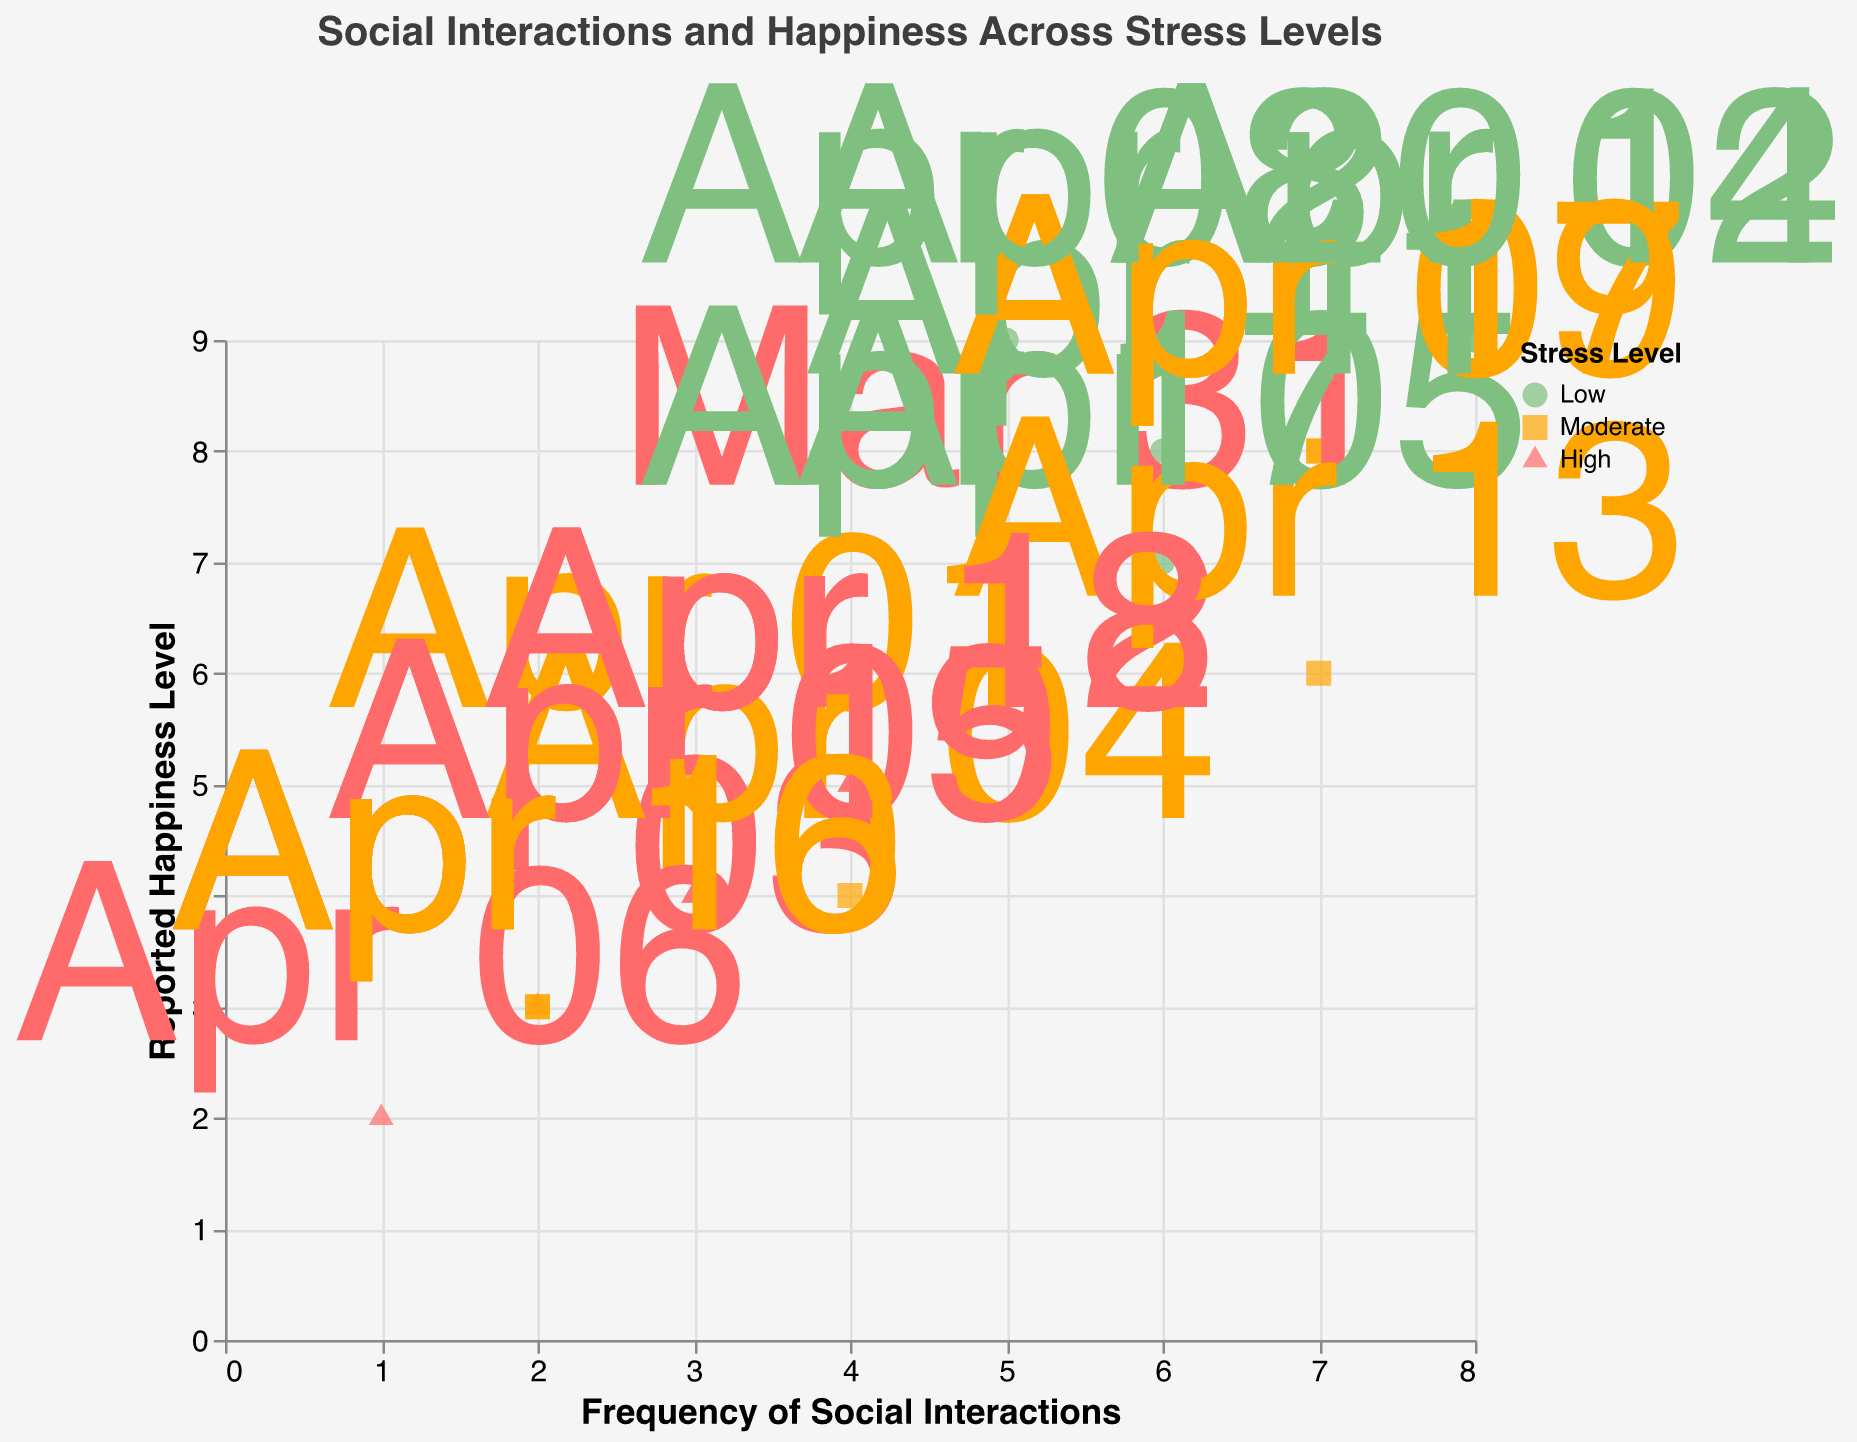What is the title of the plot? The title of the plot is usually the most prominent text, located at the top. It describes the content of the visual representation.
Answer: Social Interactions and Happiness Across Stress Levels How many different stress levels are represented in the figure? The legend in the figure indicates the different categories of stress levels through colors and shapes. By looking at the legend, we can count these categories.
Answer: Three (Low, Moderate, High) Which stress level is associated with the highest reported happiness level? Look for the data points with the highest value on the "Reported Happiness Level" axis. Check the corresponding color and shape to determine the associated stress level.
Answer: Low Compare the frequency of social interactions for the highest reported happiness level between 'Low' and 'High' stress levels. Which one is higher? Identify the data points with the highest reported happiness level for both 'Low' and 'High' stress levels. Compare their "Frequency of Social Interactions" values.
Answer: Low is higher (8 vs. 3) What is the median frequency of social interactions for 'High' stress level? List down all frequency values for 'High' stress level, sort them and find the middle value.
Answer: (1, 2, 3, 4, 5) -> Median = 3 Which date has the lowest frequency of social interactions, and what is the reported happiness level on that date? Identify the data point with the lowest value on the "Frequency of Social Interactions" axis. Check its "Date" and "Reported Happiness Level" using the tooltip or labels.
Answer: April 7, Reported Happiness Level = 2 Summarize the relationship between happiness level and frequency of social interactions for 'Low' stress level. Analyze the trend between "Frequency of Social Interactions" and "Reported Happiness Level" for data points marked as 'Low' stress level.
Answer: Generally positive correlation 